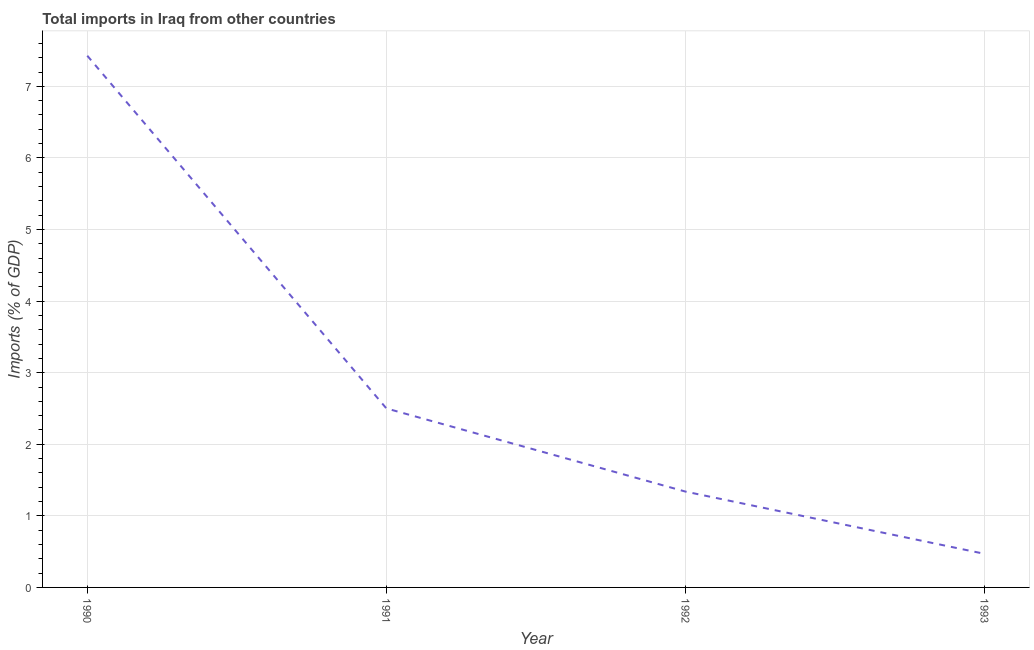What is the total imports in 1990?
Offer a very short reply. 7.43. Across all years, what is the maximum total imports?
Provide a short and direct response. 7.43. Across all years, what is the minimum total imports?
Your answer should be compact. 0.47. In which year was the total imports maximum?
Make the answer very short. 1990. What is the sum of the total imports?
Provide a succinct answer. 11.74. What is the difference between the total imports in 1992 and 1993?
Your answer should be compact. 0.87. What is the average total imports per year?
Your answer should be compact. 2.93. What is the median total imports?
Ensure brevity in your answer.  1.92. Do a majority of the years between 1990 and 1992 (inclusive) have total imports greater than 0.6000000000000001 %?
Provide a short and direct response. Yes. What is the ratio of the total imports in 1990 to that in 1992?
Offer a terse response. 5.55. What is the difference between the highest and the second highest total imports?
Provide a short and direct response. 4.93. What is the difference between the highest and the lowest total imports?
Give a very brief answer. 6.96. Does the total imports monotonically increase over the years?
Give a very brief answer. No. How many lines are there?
Your answer should be very brief. 1. What is the title of the graph?
Your answer should be very brief. Total imports in Iraq from other countries. What is the label or title of the Y-axis?
Your response must be concise. Imports (% of GDP). What is the Imports (% of GDP) in 1990?
Give a very brief answer. 7.43. What is the Imports (% of GDP) of 1991?
Ensure brevity in your answer.  2.5. What is the Imports (% of GDP) in 1992?
Offer a terse response. 1.34. What is the Imports (% of GDP) of 1993?
Your response must be concise. 0.47. What is the difference between the Imports (% of GDP) in 1990 and 1991?
Provide a succinct answer. 4.93. What is the difference between the Imports (% of GDP) in 1990 and 1992?
Keep it short and to the point. 6.09. What is the difference between the Imports (% of GDP) in 1990 and 1993?
Offer a very short reply. 6.96. What is the difference between the Imports (% of GDP) in 1991 and 1992?
Provide a short and direct response. 1.16. What is the difference between the Imports (% of GDP) in 1991 and 1993?
Offer a very short reply. 2.03. What is the difference between the Imports (% of GDP) in 1992 and 1993?
Your response must be concise. 0.87. What is the ratio of the Imports (% of GDP) in 1990 to that in 1991?
Provide a succinct answer. 2.97. What is the ratio of the Imports (% of GDP) in 1990 to that in 1992?
Provide a short and direct response. 5.55. What is the ratio of the Imports (% of GDP) in 1990 to that in 1993?
Ensure brevity in your answer.  15.83. What is the ratio of the Imports (% of GDP) in 1991 to that in 1992?
Keep it short and to the point. 1.87. What is the ratio of the Imports (% of GDP) in 1991 to that in 1993?
Ensure brevity in your answer.  5.33. What is the ratio of the Imports (% of GDP) in 1992 to that in 1993?
Ensure brevity in your answer.  2.85. 